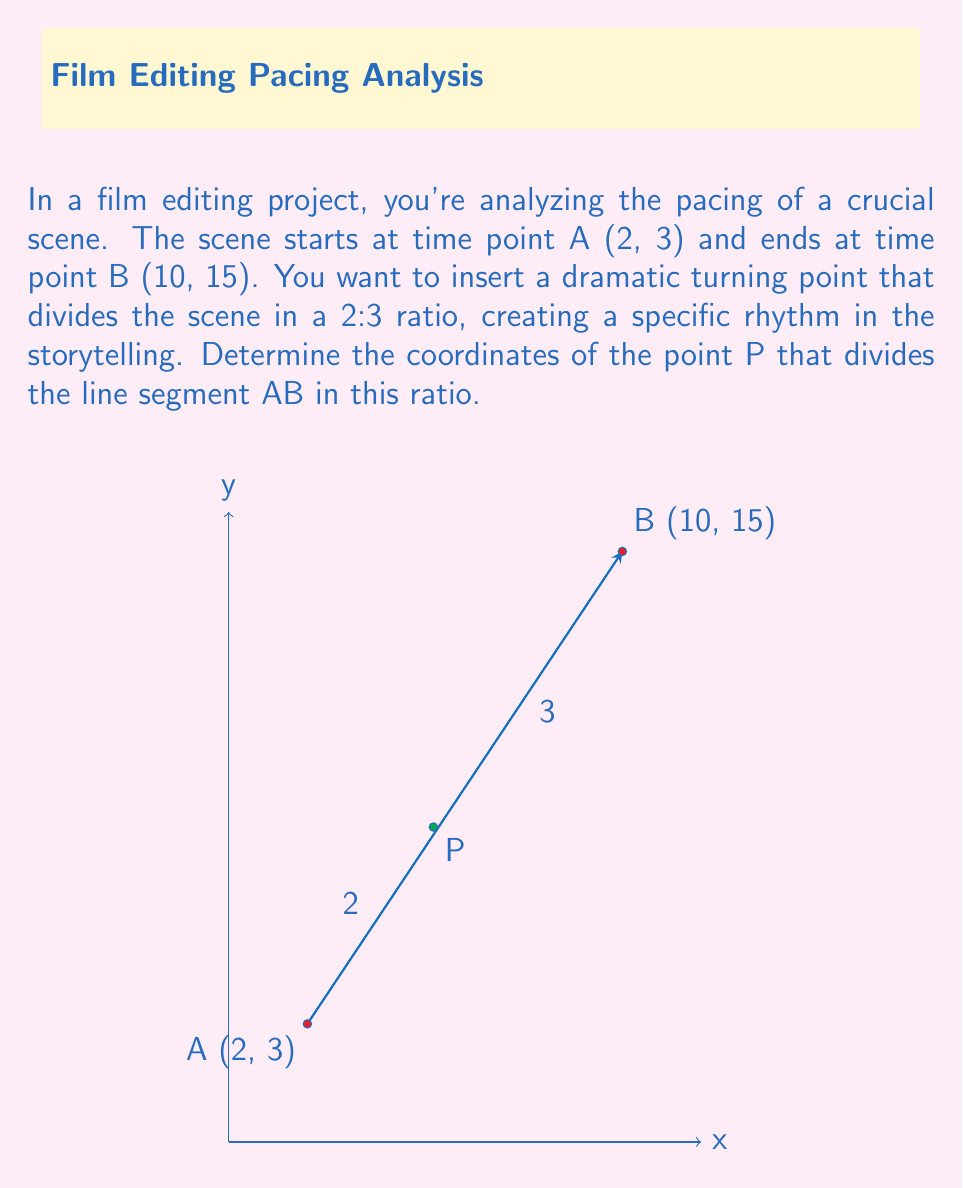Teach me how to tackle this problem. To solve this problem, we can use the section formula. Given two points $(x_1, y_1)$ and $(x_2, y_2)$, the point $P(x, y)$ that divides the line segment in the ratio $m:n$ is given by:

$$x = \frac{mx_2 + nx_1}{m + n}, \quad y = \frac{my_2 + ny_1}{m + n}$$

In this case:
- $A(x_1, y_1) = (2, 3)$
- $B(x_2, y_2) = (10, 15)$
- The ratio is $2:3$, so $m = 2$ and $n = 3$

Let's calculate the x-coordinate first:

$$x = \frac{2(10) + 3(2)}{2 + 3} = \frac{20 + 6}{5} = \frac{26}{5} = 5.2$$

Now, let's calculate the y-coordinate:

$$y = \frac{2(15) + 3(3)}{2 + 3} = \frac{30 + 9}{5} = \frac{39}{5} = 7.8$$

Therefore, the point P that divides the line segment AB in a 2:3 ratio has coordinates (5.2, 7.8).

This point represents the optimal position for the dramatic turning point in your scene, balancing the pacing between the beginning and end to create the desired storytelling rhythm.
Answer: $(5.2, 7.8)$ 